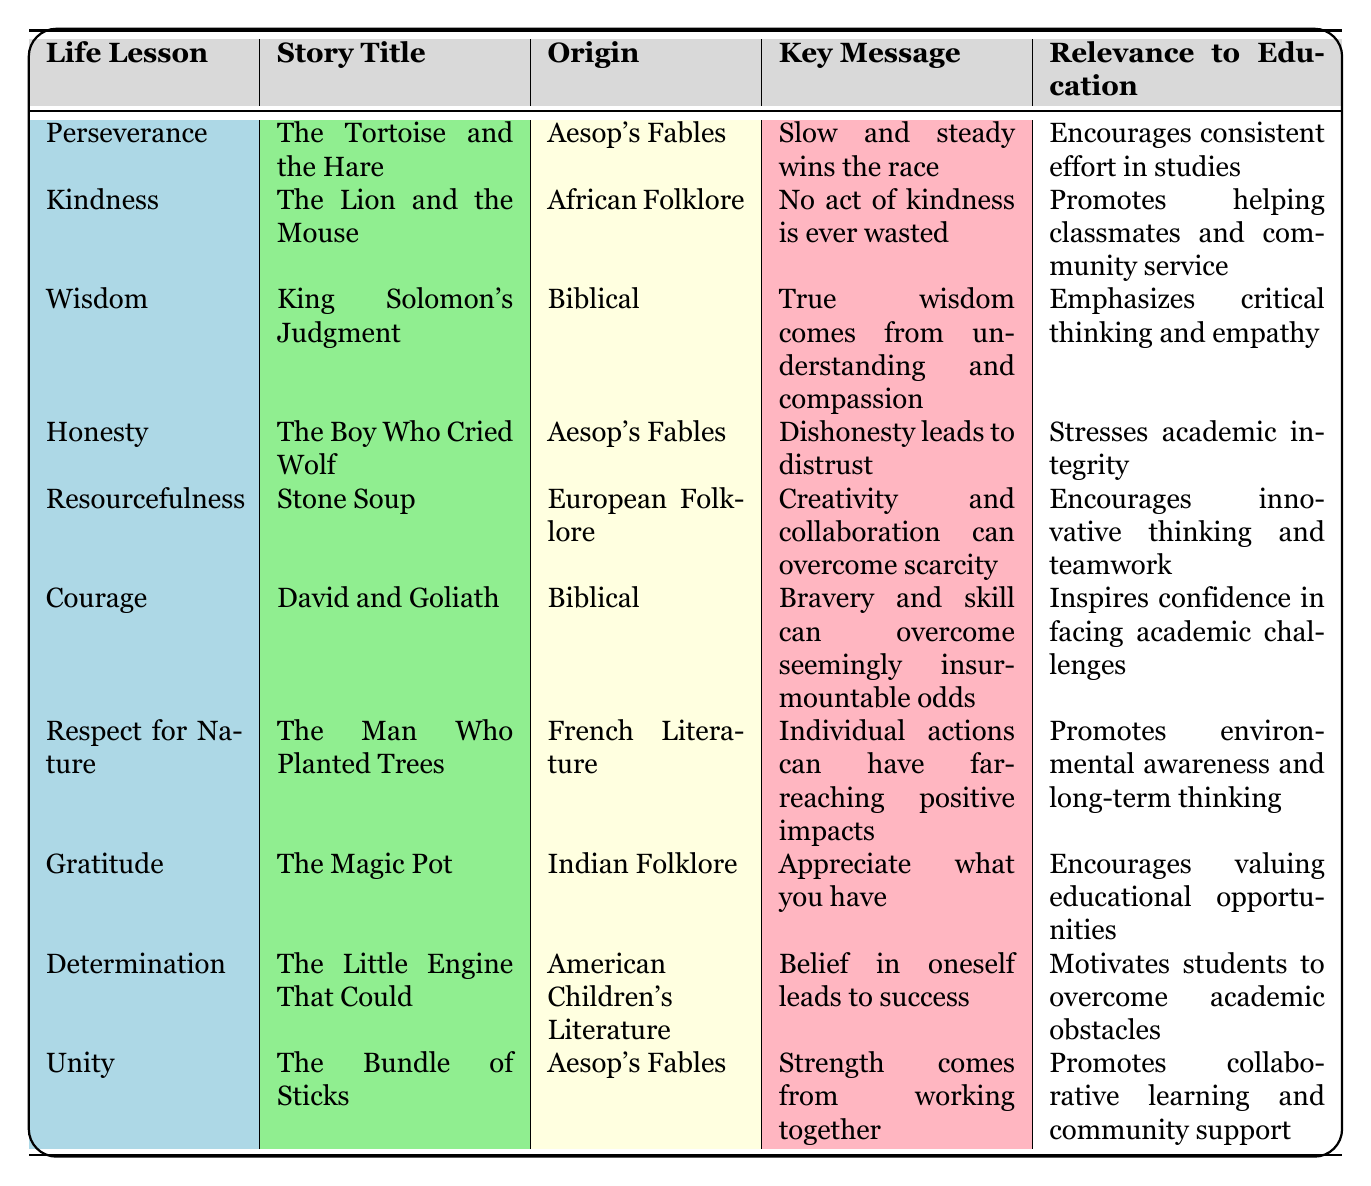What is the key message of "The Boy Who Cried Wolf"? The table states that the key message of "The Boy Who Cried Wolf" is that dishonesty leads to distrust.
Answer: Dishonesty leads to distrust Which story teaches a lesson about resourcefulness? According to the table, "Stone Soup" is the story that teaches a lesson about resourcefulness.
Answer: Stone Soup How many stories originate from Aesop's Fables? There are three stories listed in the table that originate from Aesop's Fables: "The Tortoise and the Hare," "The Boy Who Cried Wolf," and "The Bundle of Sticks."
Answer: Three stories Is the story "David and Goliath" related to courage? Yes, the table clearly states that "David and Goliath" relates to the life lesson of courage.
Answer: Yes Which life lesson emphasizes critical thinking and empathy? The table shows that the life lesson that emphasizes critical thinking and empathy is wisdom, which comes from the story "King Solomon's Judgment."
Answer: Wisdom What percentage of the stories listed are about kindness or gratitude? The total number of stories is 10. The stories related to kindness ("The Lion and the Mouse") and gratitude ("The Magic Pot") are 2 out of 10. Therefore, the percentage is (2/10) * 100 = 20%.
Answer: 20% Which story emphasizes the strength of unity? "The Bundle of Sticks" emphasizes the strength of unity, as stated in the table.
Answer: The Bundle of Sticks What is the relevance to education of the story "The Man Who Planted Trees"? According to the table, the relevance to education of "The Man Who Planted Trees" is that it promotes environmental awareness and long-term thinking.
Answer: Promotes environmental awareness and long-term thinking If you combine the lessons of courage and determination, what do they inspire students to do? The combined lessons of courage from "David and Goliath" and determination from "The Little Engine That Could" inspire students to face academic challenges with confidence and to believe in their ability to succeed.
Answer: Face academic challenges with confidence and believe in their ability to succeed 